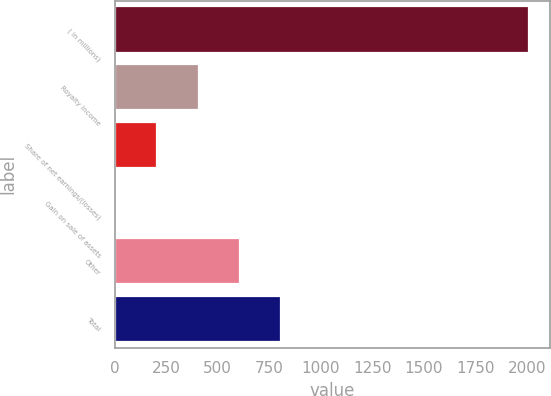Convert chart to OTSL. <chart><loc_0><loc_0><loc_500><loc_500><bar_chart><fcel>( in millions)<fcel>Royalty income<fcel>Share of net earnings/(losses)<fcel>Gain on sale of assets<fcel>Other<fcel>Total<nl><fcel>2013<fcel>407.4<fcel>206.7<fcel>6<fcel>608.1<fcel>808.8<nl></chart> 